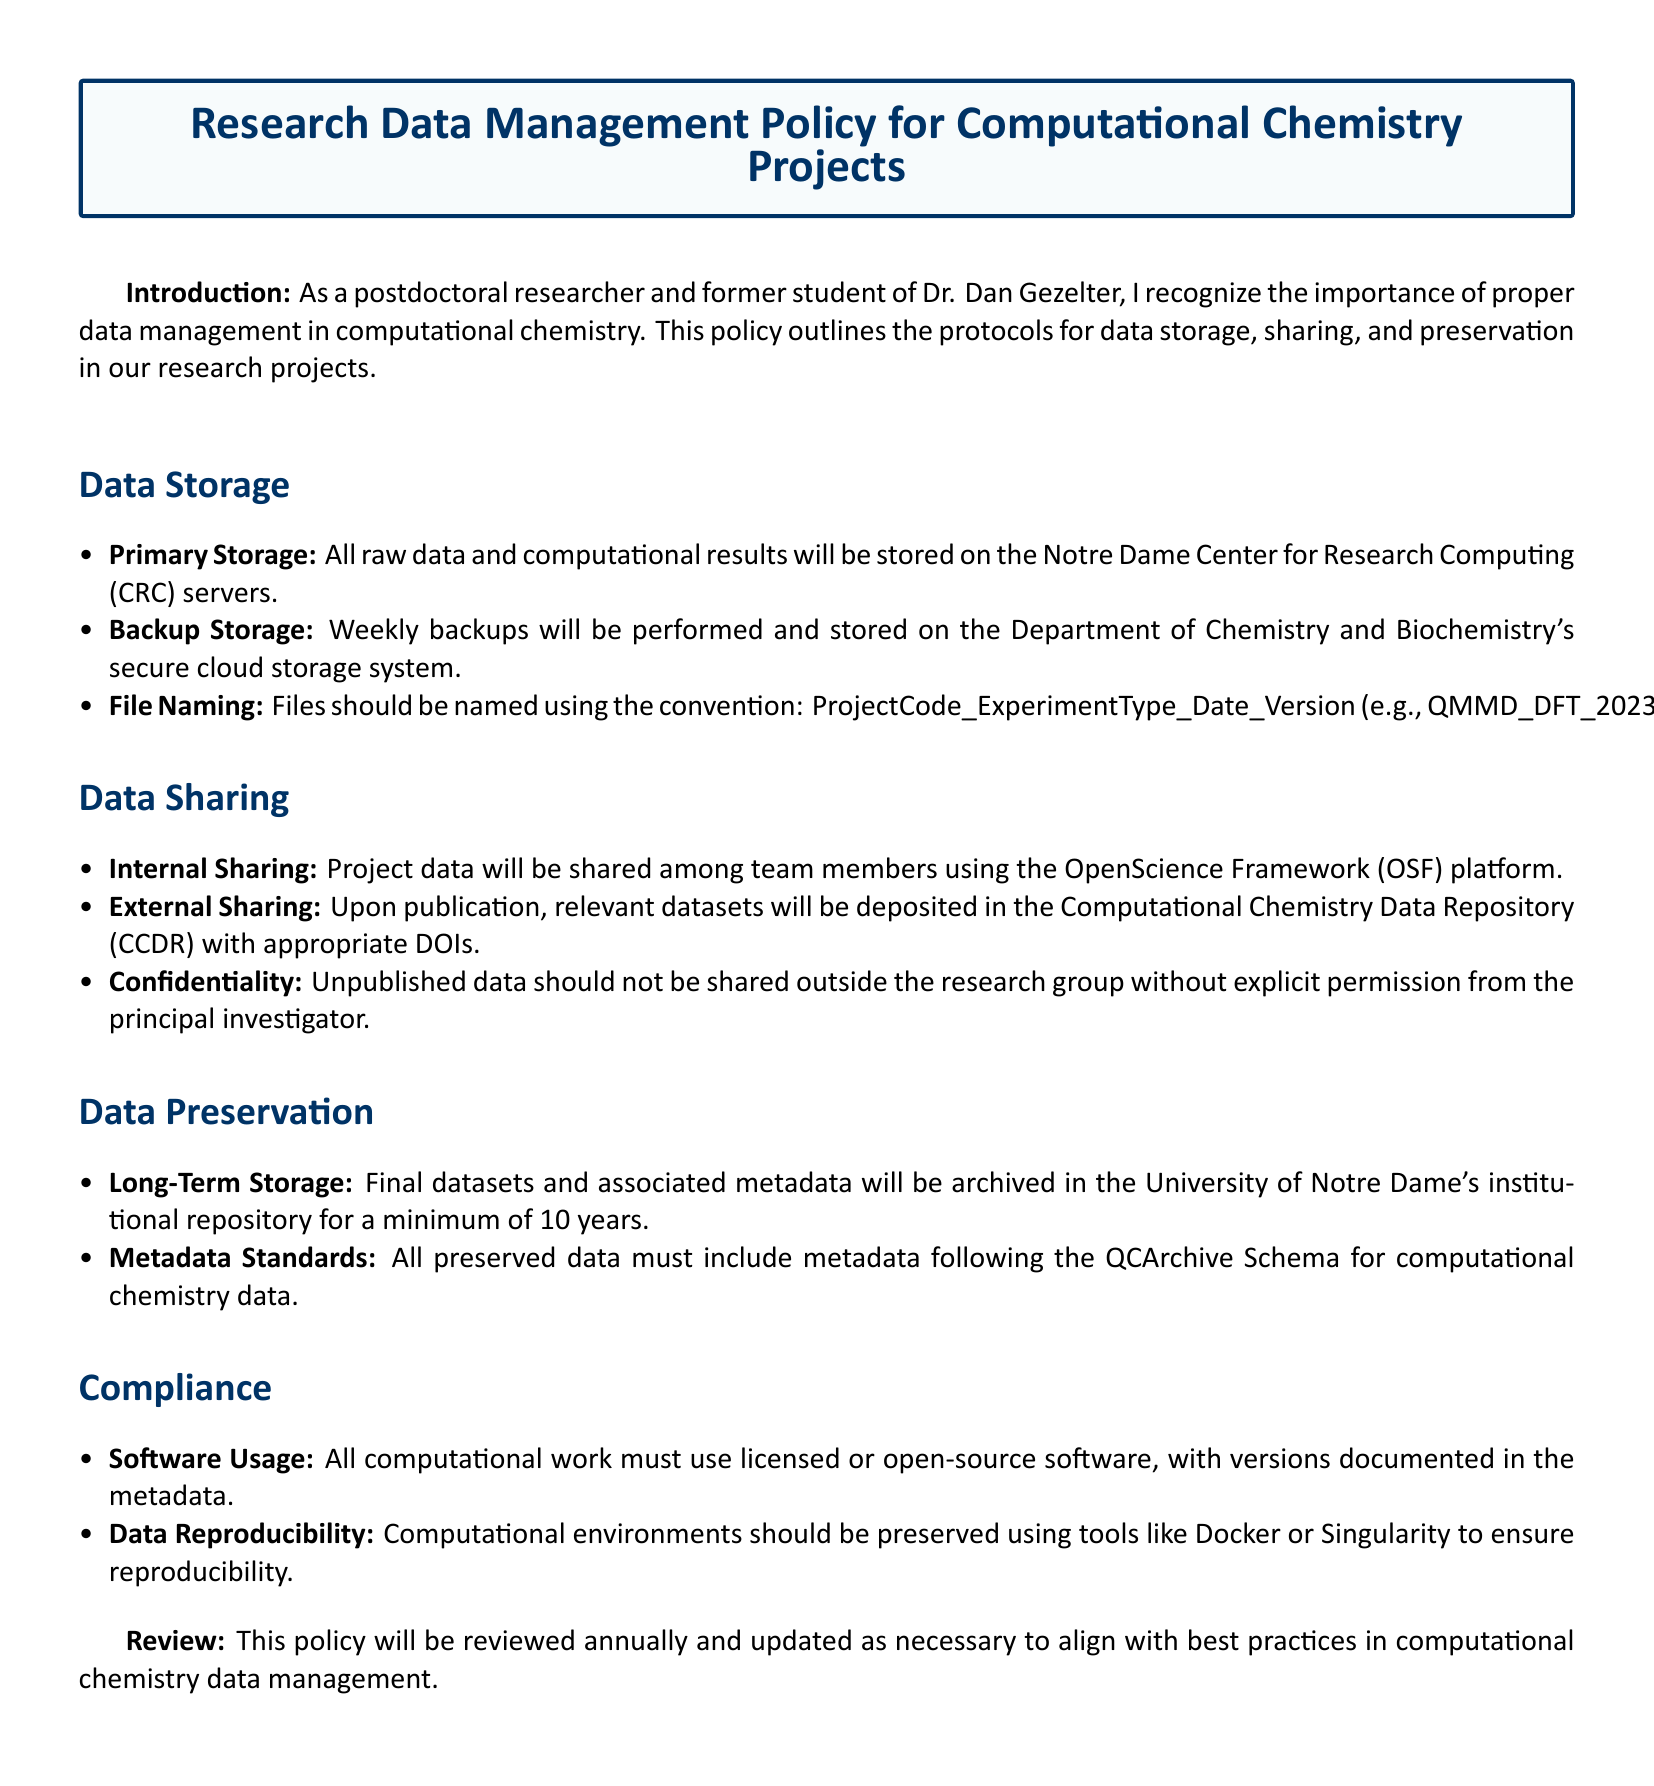What is the primary storage location for data? The primary storage location for data is specified as the Notre Dame Center for Research Computing servers in the document.
Answer: Notre Dame Center for Research Computing servers How often are backups performed? The document states that backups will be performed weekly, which is an important aspect of data management.
Answer: Weekly What is the file naming convention used? The policy describes the file naming convention as ProjectCode_ExperimentType_Date_Version, providing clarity for data organization.
Answer: ProjectCode_ExperimentType_Date_Version Where will datasets be deposited upon publication? The document mentions that relevant datasets will be deposited in the Computational Chemistry Data Repository after publication.
Answer: Computational Chemistry Data Repository What is the minimum duration for long-term storage of final datasets? According to the policy, final datasets and associated metadata must be archived for a minimum of 10 years, highlighting a commitment to data preservation.
Answer: 10 years What standards must metadata follow for preserved data? The document specifies that metadata must adhere to the QCArchive Schema for computational chemistry data, ensuring consistency and usability.
Answer: QCArchive Schema What tools are recommended for preserving computational environments? The policy recommends using Docker or Singularity to preserve computational environments, which is crucial for reproducibility.
Answer: Docker or Singularity What is the review frequency of this policy? The document states that the policy will be reviewed annually, which is essential for keeping data management practices up to date.
Answer: Annually 